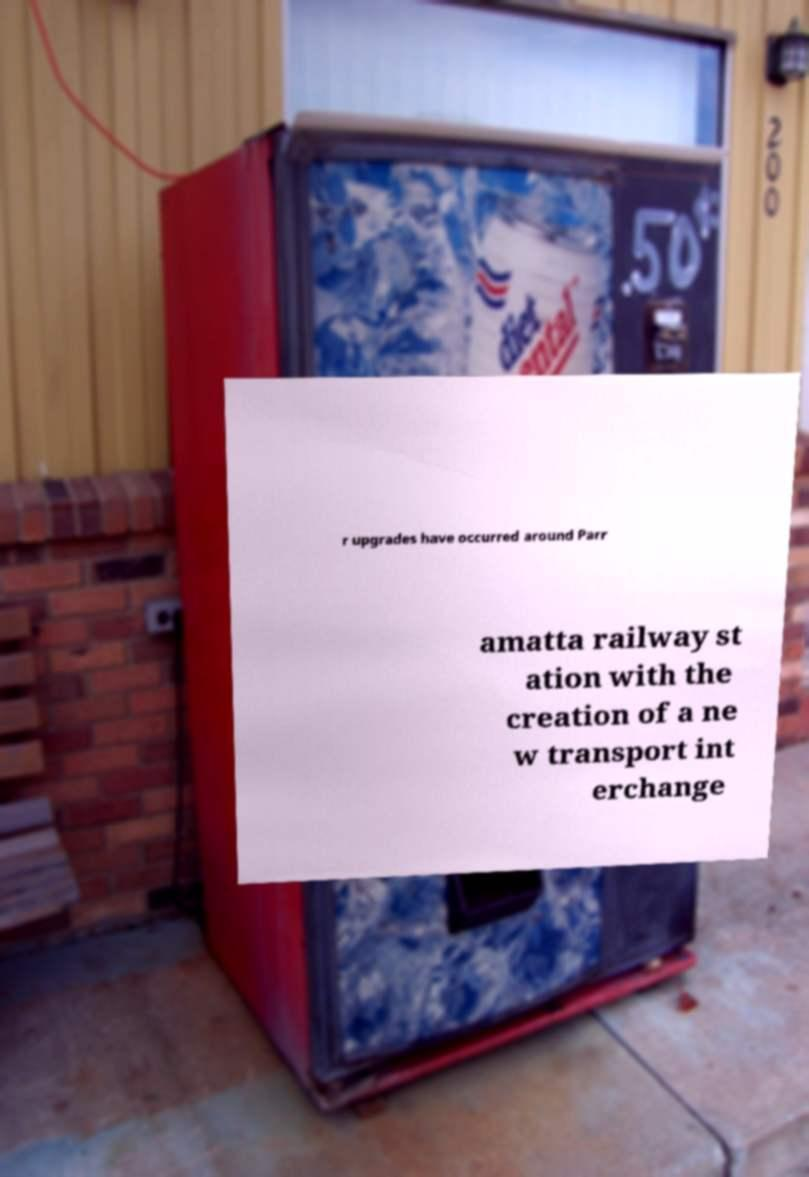For documentation purposes, I need the text within this image transcribed. Could you provide that? r upgrades have occurred around Parr amatta railway st ation with the creation of a ne w transport int erchange 